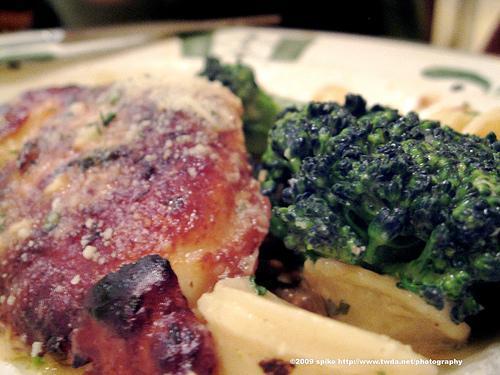How many food items do you see?
Give a very brief answer. 3. 